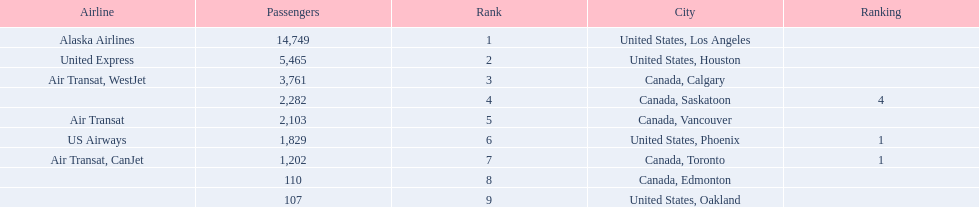What are the cities flown to? United States, Los Angeles, United States, Houston, Canada, Calgary, Canada, Saskatoon, Canada, Vancouver, United States, Phoenix, Canada, Toronto, Canada, Edmonton, United States, Oakland. What number of passengers did pheonix have? 1,829. 